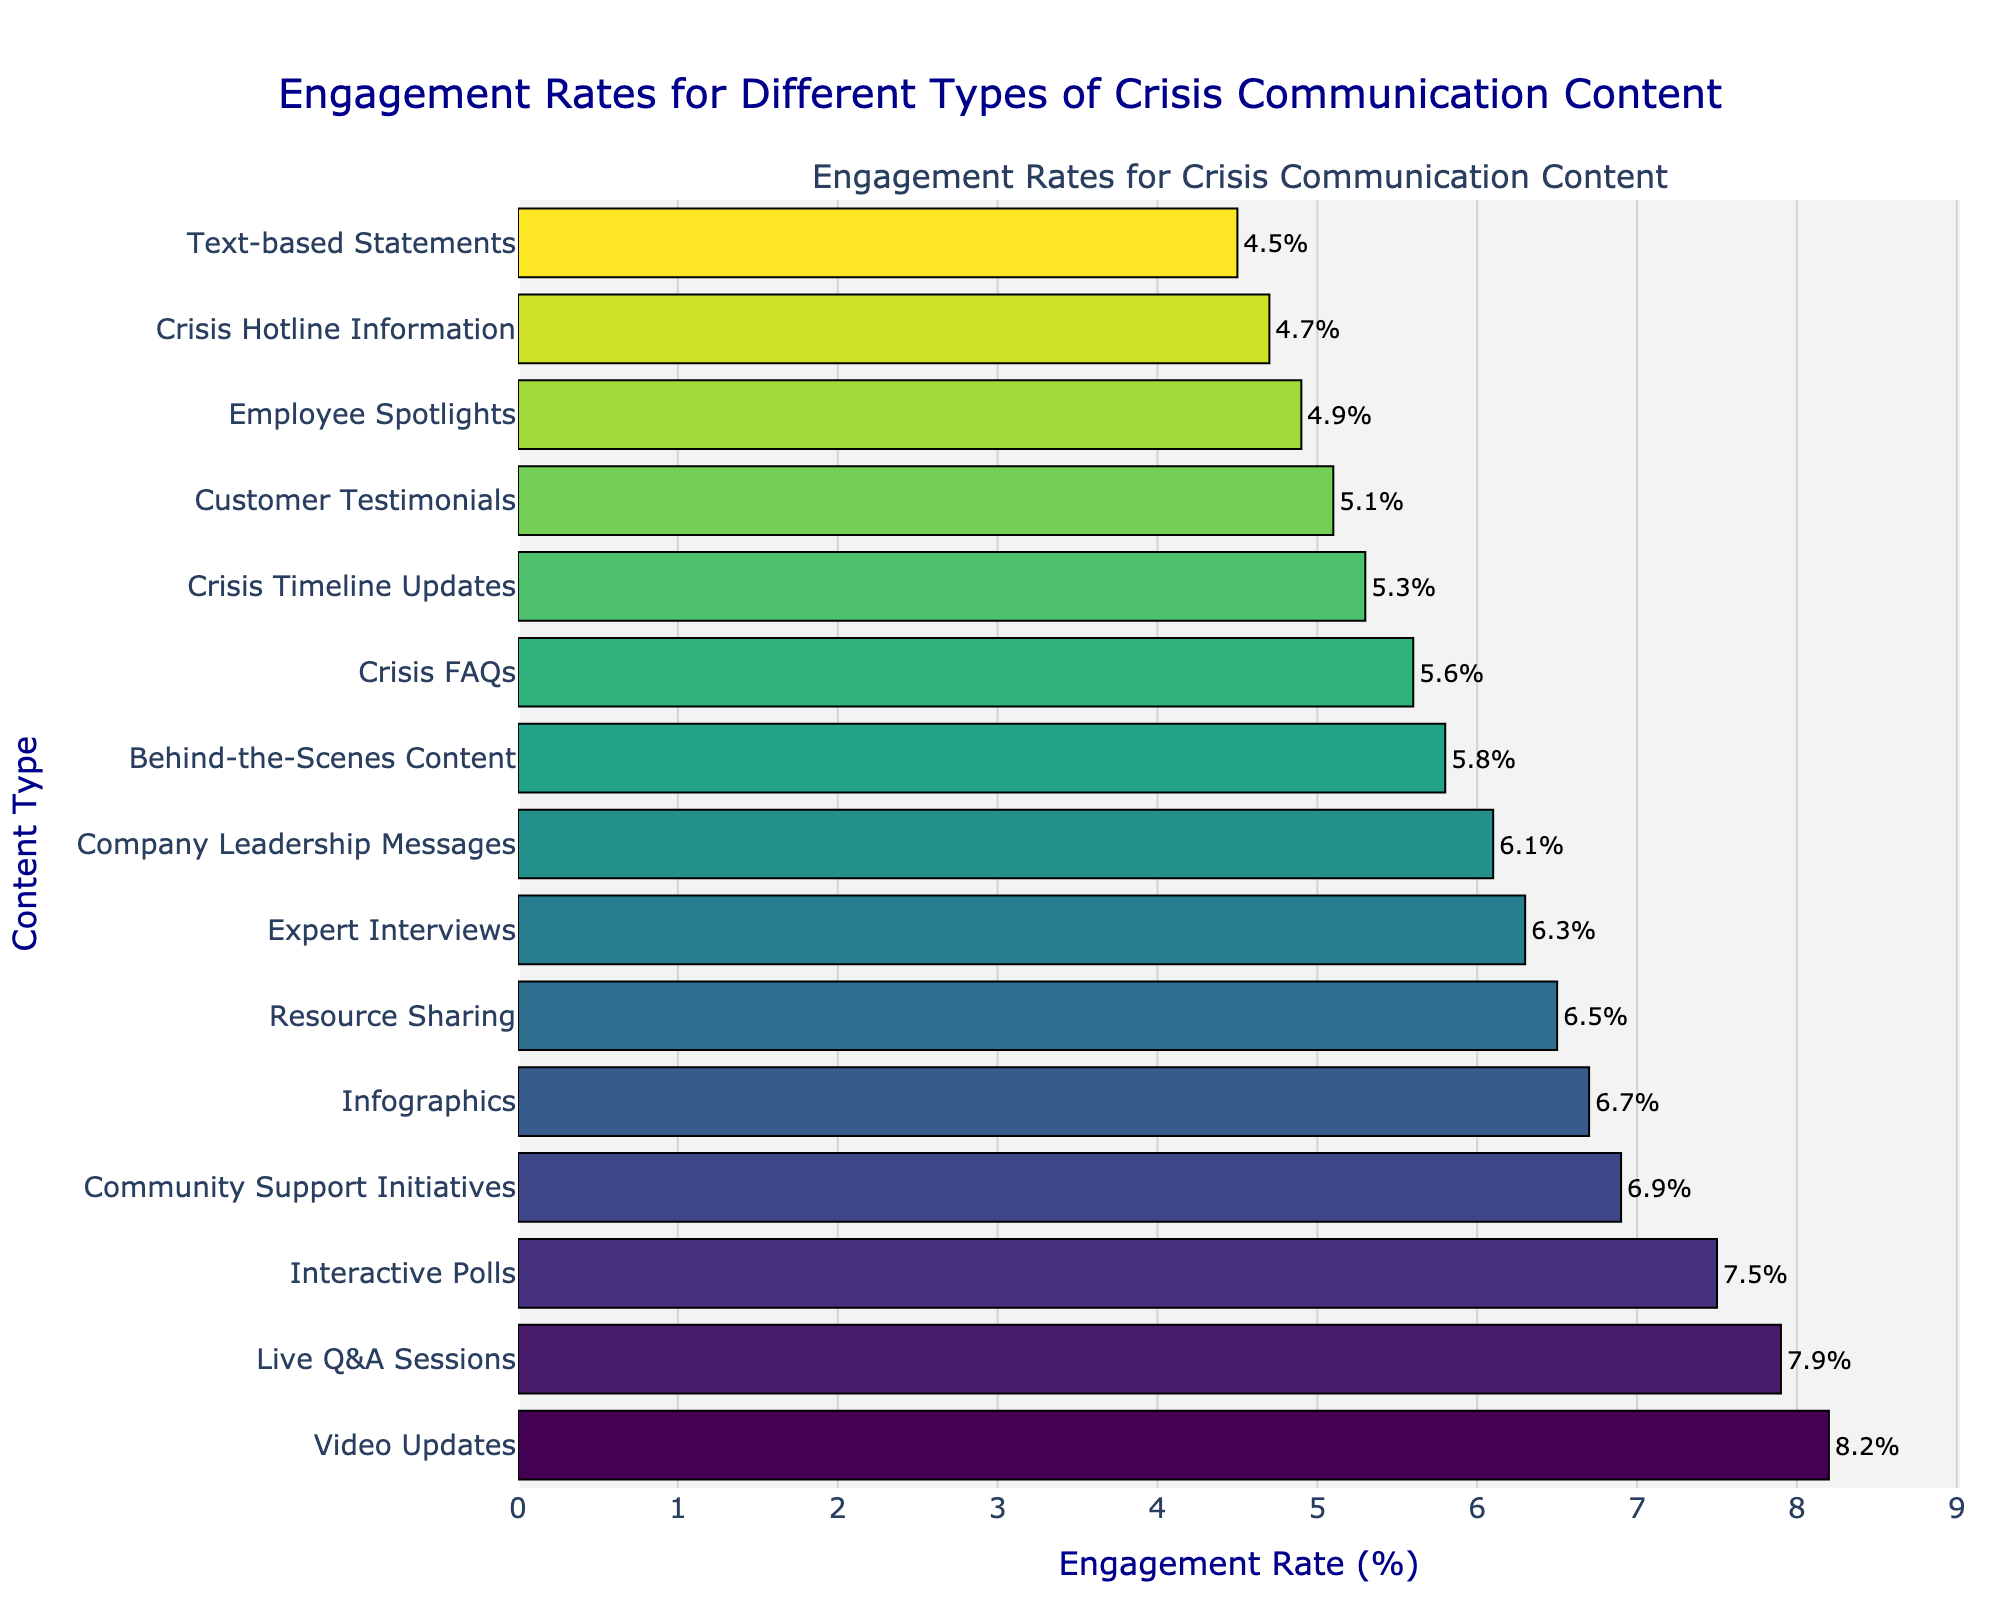Which type of crisis communication content has the highest engagement rate? By looking at the top of the sorted bar chart, the tallest bar represents the type with the highest engagement rate.
Answer: Video Updates How does the engagement rate of Live Q&A Sessions compare to that of Interactive Polls? Live Q&A Sessions have an engagement rate of 7.9%, while Interactive Polls have an engagement rate of 7.5%. The engagement rate of Live Q&A Sessions is higher than that of Interactive Polls.
Answer: Live Q&A Sessions are higher What is the engagement rate difference between Behind-the-Scenes Content and Employee Spotlights? The engagement rate for Behind-the-Scenes Content is 5.8%, and for Employee Spotlights, it is 4.9%. Subtracting these gives 5.8% - 4.9% = 0.9%.
Answer: 0.9% Which type of content has a higher engagement rate: Crisis Timeline Updates or Resource Sharing? Crisis Timeline Updates have an engagement rate of 5.3%, while Resource Sharing has an engagement rate of 6.5%. Resource Sharing has a higher engagement rate.
Answer: Resource Sharing Out of Infographics, Expert Interviews, and Customer Testimonials, which has the lowest engagement rate, and what is it? The engagement rates are Infographics (6.7%), Expert Interviews (6.3%), and Customer Testimonials (5.1%). The lowest engagement rate among these is for Customer Testimonials.
Answer: Customer Testimonials, 5.1% What is the average engagement rate of Community Support Initiatives, Crisis FAQs, and Company Leadership Messages? The engagement rates are Community Support Initiatives (6.9%), Crisis FAQs (5.6%), and Company Leadership Messages (6.1%). The average is (6.9 + 5.6 + 6.1) / 3 = 6.2%.
Answer: 6.2% Which color scheme is used to highlight the engagement rates on the bar chart? By visually examining the colors on the bars, we can see that a gradient of the color scheme from light to dark, typical of the Viridis colorscale, is used.
Answer: Viridis What is the total engagement rate if we sum the rates of Text-based Statements, Crisis Hotline Information, and Customer Testimonials? The engagement rates are Text-based Statements (4.5%), Crisis Hotline Information (4.7%), and Customer Testimonials (5.1%). The total is 4.5 + 4.7 + 5.1 = 14.3%.
Answer: 14.3% Are the engagement rates of Video Updates and Live Q&A Sessions equal? By checking each bar, we see that Video Updates have an engagement rate of 8.2%, and Live Q&A Sessions have an engagement rate of 7.9%. These rates are not equal.
Answer: No 